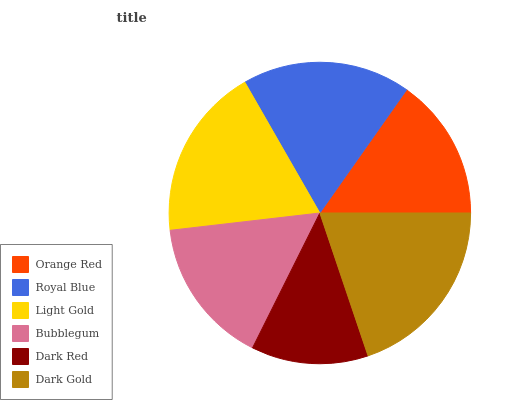Is Dark Red the minimum?
Answer yes or no. Yes. Is Dark Gold the maximum?
Answer yes or no. Yes. Is Royal Blue the minimum?
Answer yes or no. No. Is Royal Blue the maximum?
Answer yes or no. No. Is Royal Blue greater than Orange Red?
Answer yes or no. Yes. Is Orange Red less than Royal Blue?
Answer yes or no. Yes. Is Orange Red greater than Royal Blue?
Answer yes or no. No. Is Royal Blue less than Orange Red?
Answer yes or no. No. Is Royal Blue the high median?
Answer yes or no. Yes. Is Bubblegum the low median?
Answer yes or no. Yes. Is Light Gold the high median?
Answer yes or no. No. Is Light Gold the low median?
Answer yes or no. No. 